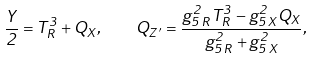<formula> <loc_0><loc_0><loc_500><loc_500>\frac { Y } { 2 } = T ^ { 3 } _ { R } + Q _ { X } , \quad Q _ { Z ^ { \prime } } = \frac { g _ { 5 \, R } ^ { 2 } T ^ { 3 } _ { R } - g _ { 5 \, X } ^ { 2 } Q _ { X } } { g _ { 5 \, R } ^ { 2 } + g _ { 5 \, X } ^ { 2 } } ,</formula> 